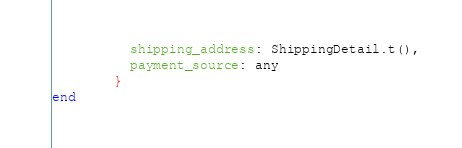<code> <loc_0><loc_0><loc_500><loc_500><_Elixir_>          shipping_address: ShippingDetail.t(),
          payment_source: any
        }
end
</code> 